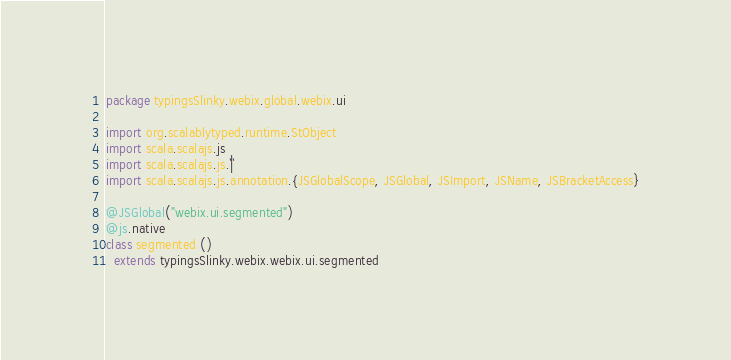Convert code to text. <code><loc_0><loc_0><loc_500><loc_500><_Scala_>package typingsSlinky.webix.global.webix.ui

import org.scalablytyped.runtime.StObject
import scala.scalajs.js
import scala.scalajs.js.`|`
import scala.scalajs.js.annotation.{JSGlobalScope, JSGlobal, JSImport, JSName, JSBracketAccess}

@JSGlobal("webix.ui.segmented")
@js.native
class segmented ()
  extends typingsSlinky.webix.webix.ui.segmented
</code> 